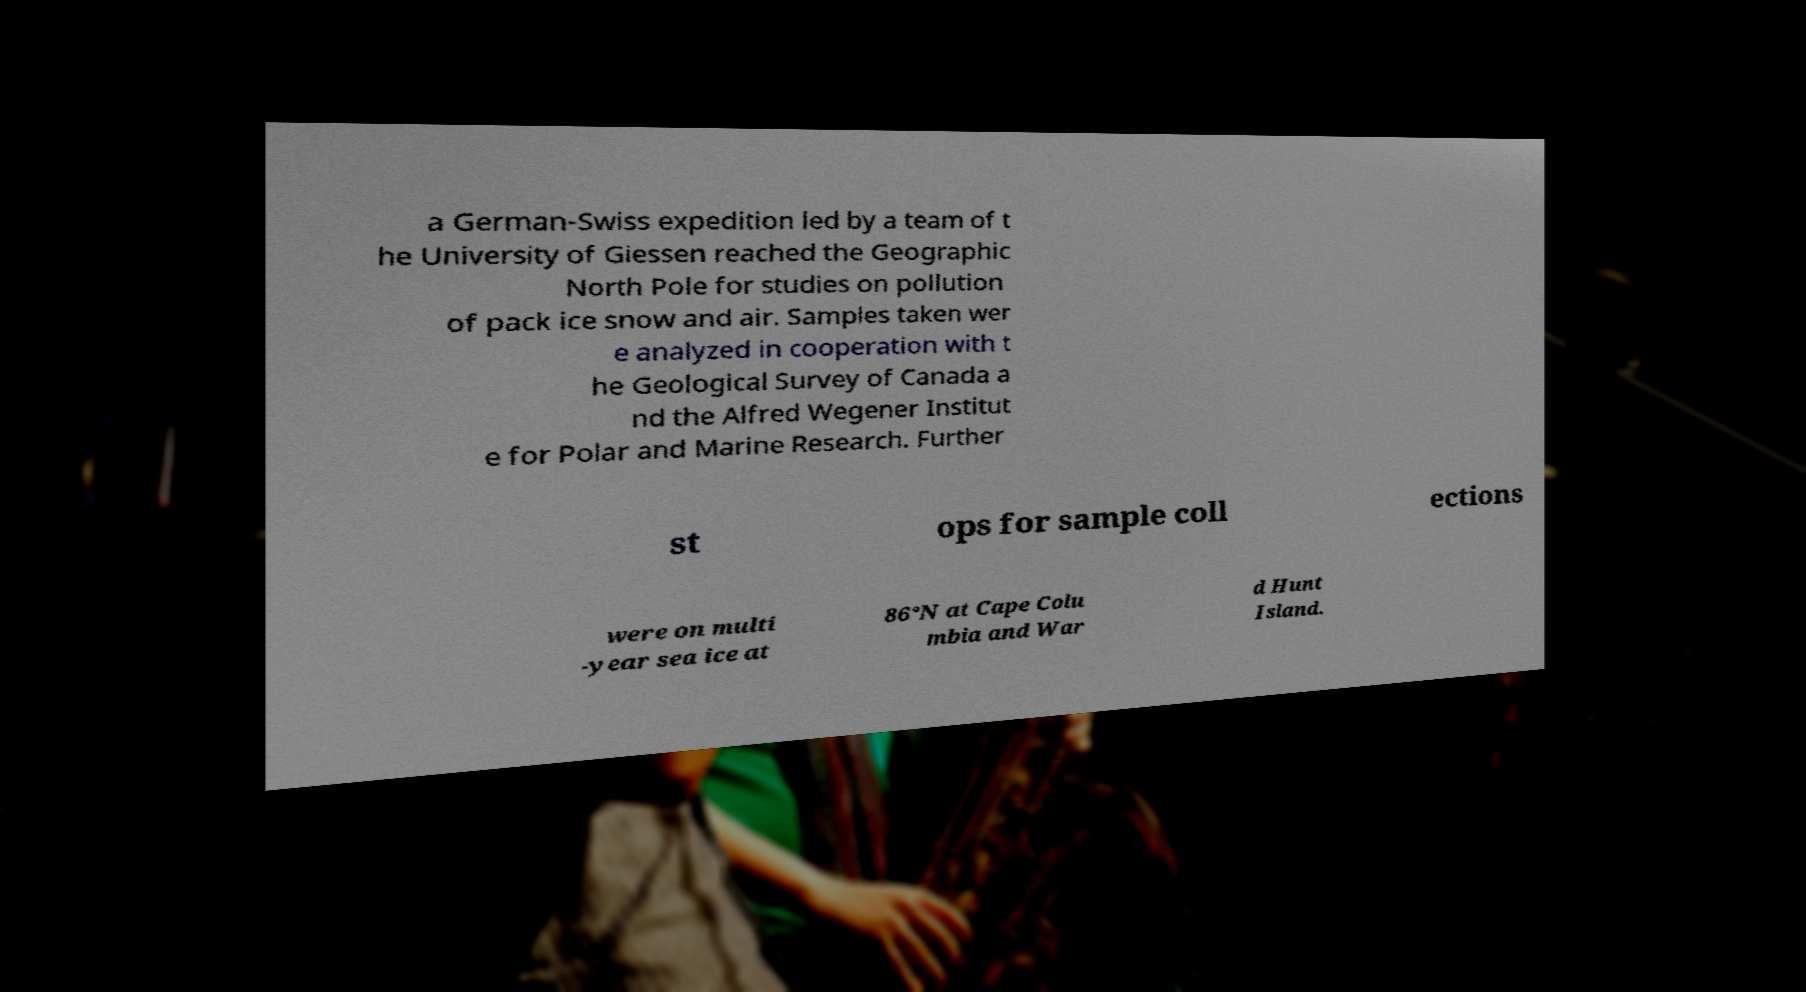Could you assist in decoding the text presented in this image and type it out clearly? a German-Swiss expedition led by a team of t he University of Giessen reached the Geographic North Pole for studies on pollution of pack ice snow and air. Samples taken wer e analyzed in cooperation with t he Geological Survey of Canada a nd the Alfred Wegener Institut e for Polar and Marine Research. Further st ops for sample coll ections were on multi -year sea ice at 86°N at Cape Colu mbia and War d Hunt Island. 